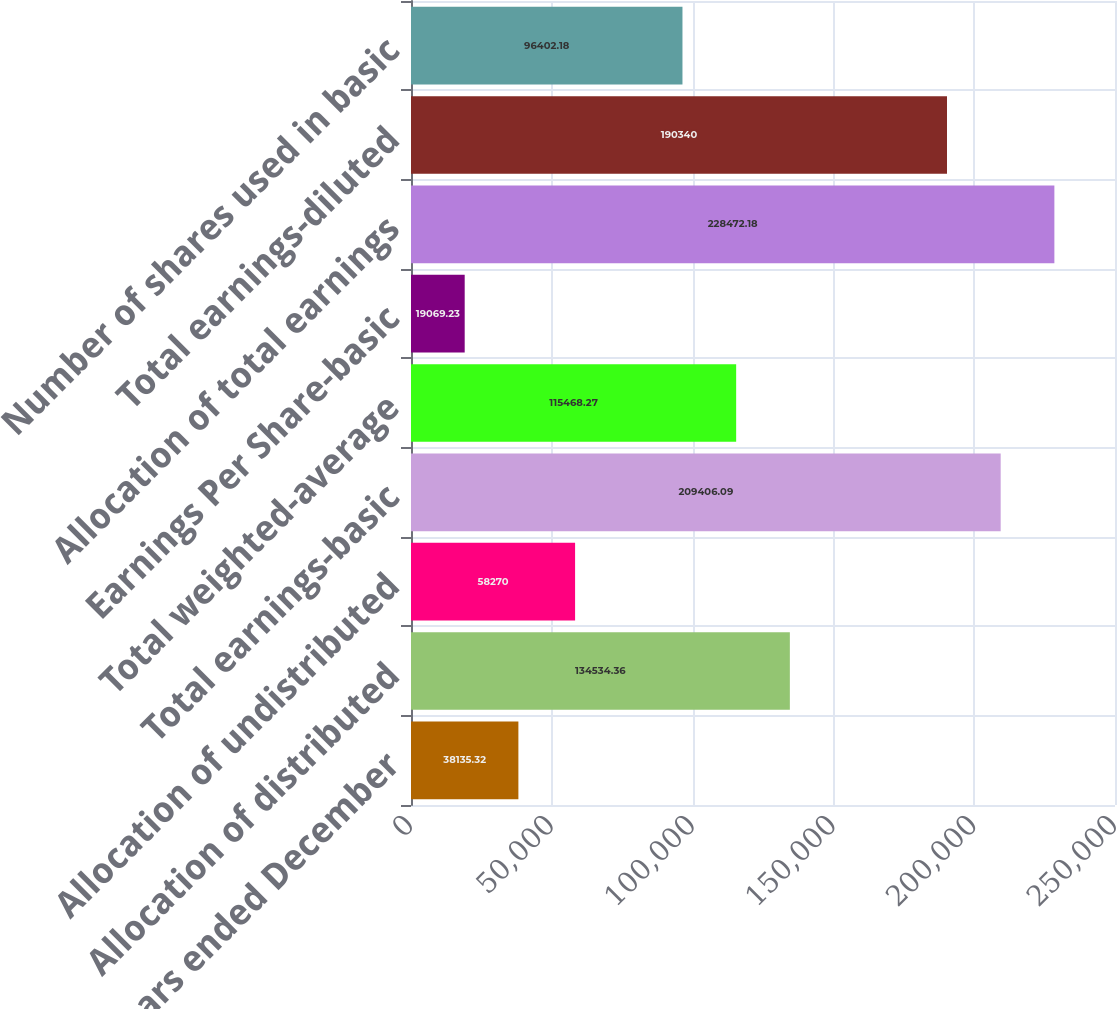Convert chart. <chart><loc_0><loc_0><loc_500><loc_500><bar_chart><fcel>For the years ended December<fcel>Allocation of distributed<fcel>Allocation of undistributed<fcel>Total earnings-basic<fcel>Total weighted-average<fcel>Earnings Per Share-basic<fcel>Allocation of total earnings<fcel>Total earnings-diluted<fcel>Number of shares used in basic<nl><fcel>38135.3<fcel>134534<fcel>58270<fcel>209406<fcel>115468<fcel>19069.2<fcel>228472<fcel>190340<fcel>96402.2<nl></chart> 